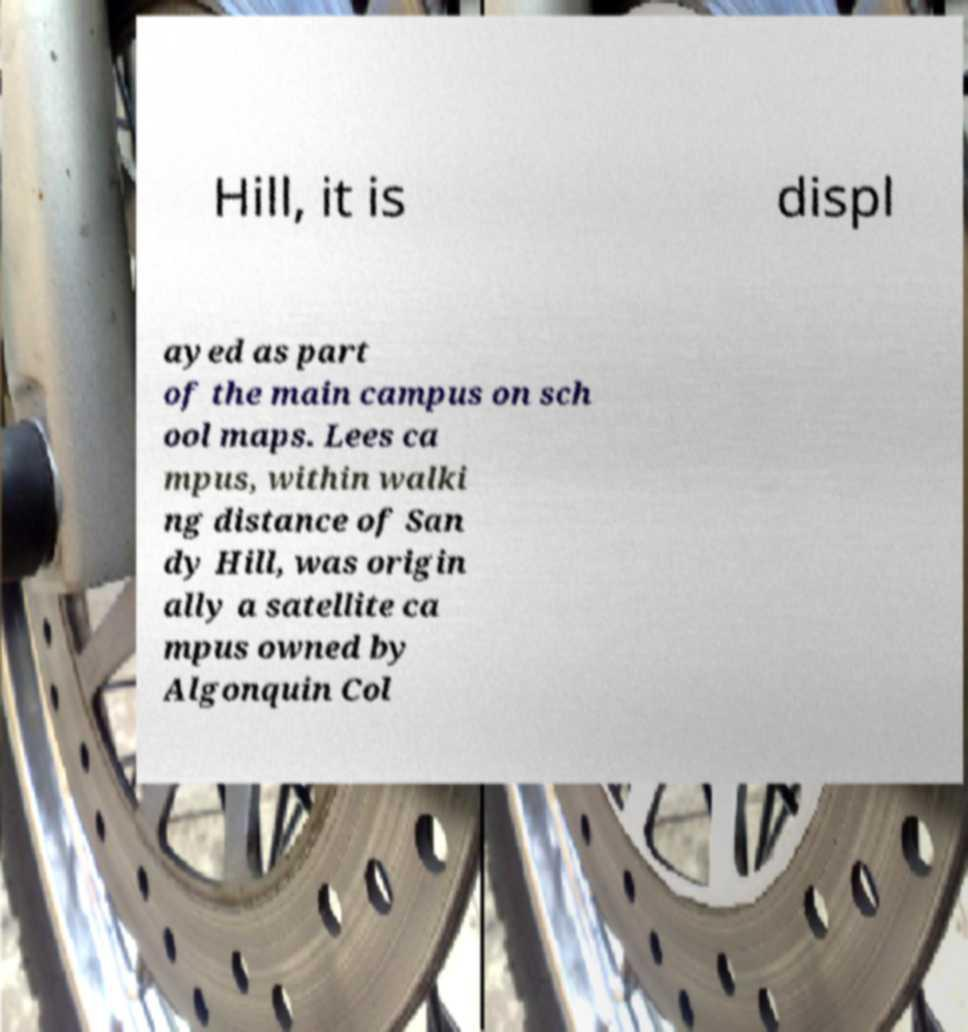For documentation purposes, I need the text within this image transcribed. Could you provide that? Hill, it is displ ayed as part of the main campus on sch ool maps. Lees ca mpus, within walki ng distance of San dy Hill, was origin ally a satellite ca mpus owned by Algonquin Col 